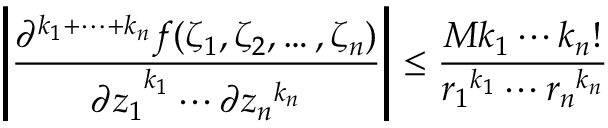<formula> <loc_0><loc_0><loc_500><loc_500>\left | { \frac { \partial ^ { k _ { 1 } + \cdots + k _ { n } } f ( \zeta _ { 1 } , \zeta _ { 2 } , \dots , \zeta _ { n } ) } { { \partial z _ { 1 } } ^ { k _ { 1 } } \cdots \partial { z _ { n } } ^ { k _ { n } } } } \right | \leq { \frac { M k _ { 1 } \cdots k _ { n } ! } { { r _ { 1 } } ^ { k _ { 1 } } \cdots { r _ { n } } ^ { k _ { n } } } }</formula> 